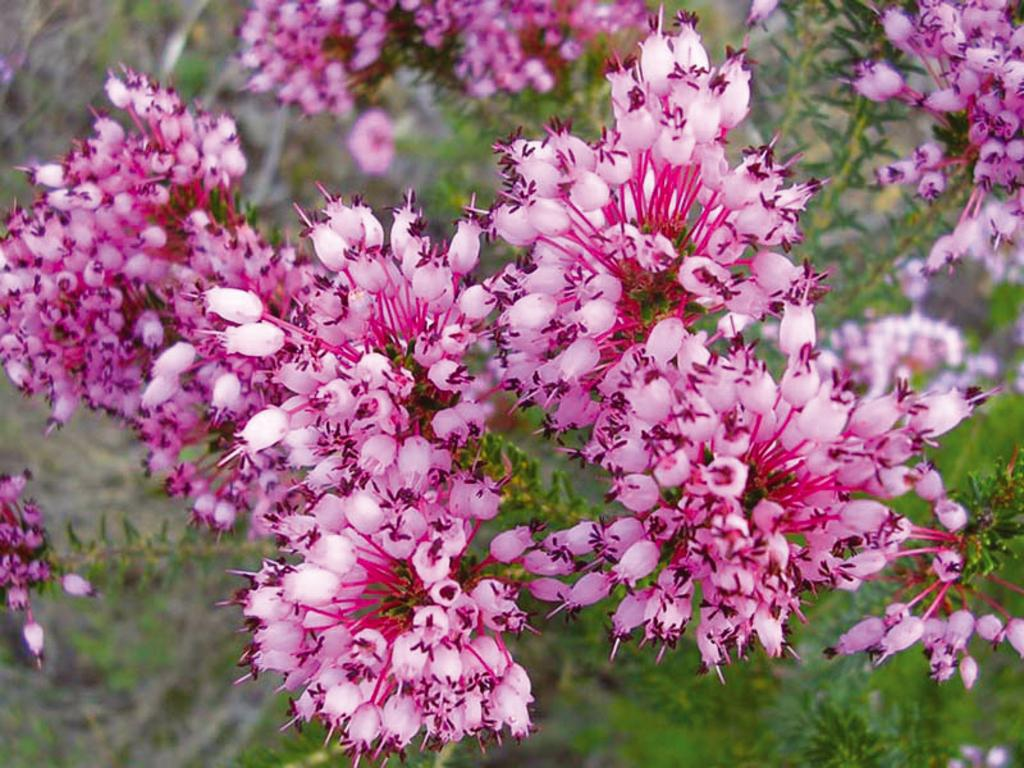What type of living organisms can be seen in the image? Plants can be seen in the image. Do the plants have any specific features? Yes, the plants have flowers. Can you tell me how many mittens are visible in the image? There are no mittens present in the image. Are the plants shown sleeping in the image? Plants do not sleep, so this question is not applicable to the image. 